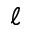Convert formula to latex. <formula><loc_0><loc_0><loc_500><loc_500>\ell</formula> 